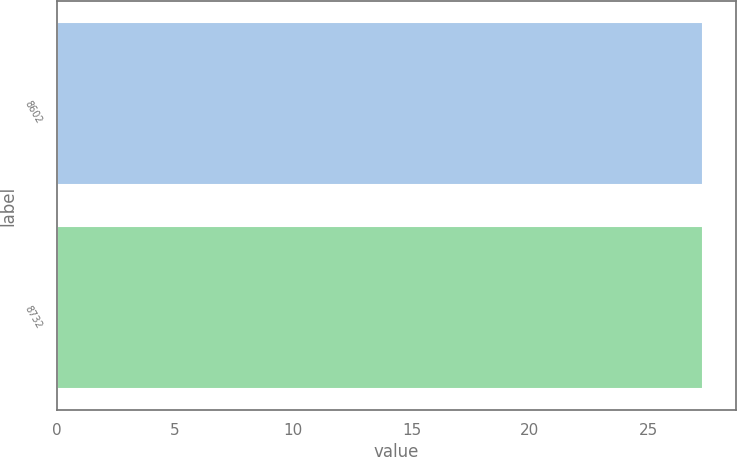<chart> <loc_0><loc_0><loc_500><loc_500><bar_chart><fcel>8602<fcel>8732<nl><fcel>27.33<fcel>27.34<nl></chart> 